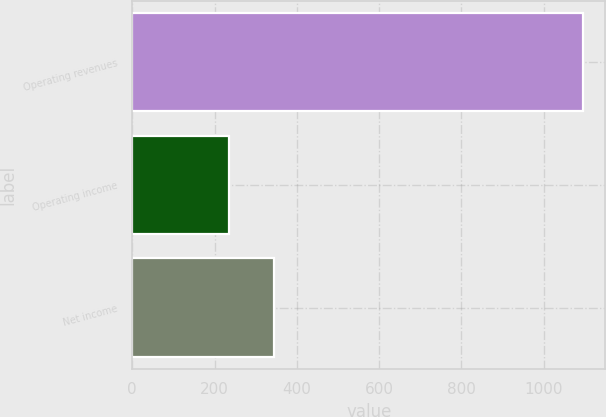Convert chart to OTSL. <chart><loc_0><loc_0><loc_500><loc_500><bar_chart><fcel>Operating revenues<fcel>Operating income<fcel>Net income<nl><fcel>1095<fcel>234<fcel>344<nl></chart> 